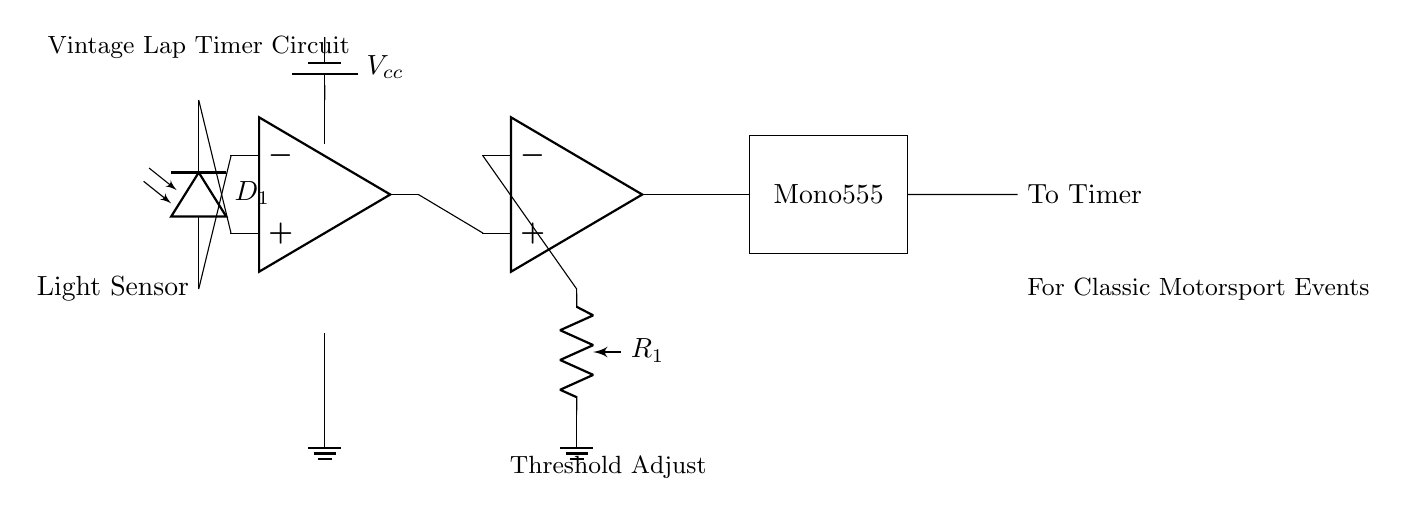What is the main purpose of the light sensor in this circuit? The light sensor detects the light beam interruption when a vehicle passes, triggering the timing mechanism.
Answer: Detecting light What is the component type designated as D1 in the circuit? D1 is a photodiode that acts as a light sensor to capture the lap timing event when the light is disrupted.
Answer: Photodiode What function does the monostable multivibrator serve in this circuit? The monostable multivibrator, represented by the 555 timer, generates a precise timing pulse when triggered by the comparator output.
Answer: Generate timing pulse How is the threshold for the comparator adjusted in this circuit? The threshold is adjusted by the potentiometer labeled R1, which sets the sensitivity of the comparator to the light signal.
Answer: Potentiometer What type of operational amplifier configuration is used in this circuit? The first op-amp is configured as a signal amplifier, and the second is used as a comparator to monitor the amplified light signal against the threshold.
Answer: Signal amplifier and comparator What triggers the transition of the monostable multivibrator? The transition is triggered by the output from the comparator, which indicates that the light beam has been interrupted.
Answer: Output from comparator 